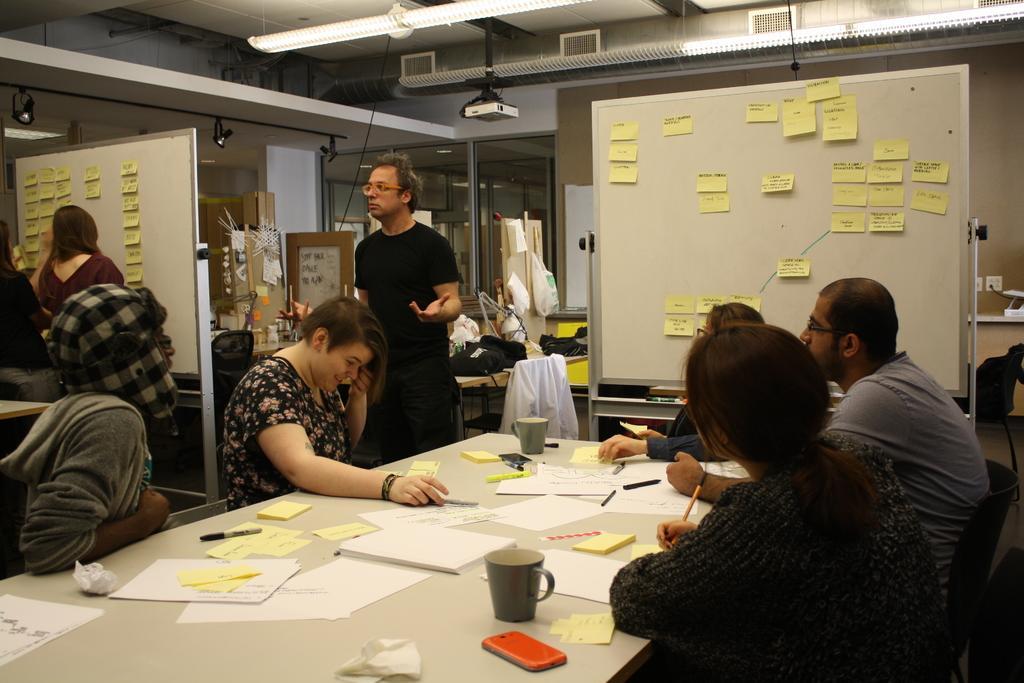Describe this image in one or two sentences. This picture describe about the inside view of the hall in which a group of girls and boys are sitting around the table and discussing something, On the table we can see papers, Yellow sticky notes, tea cup and mobile. Behind a white board with yellow stick notes and man wearing black t- shirt and track is discussing. On the top ceiling we can see the projector hanging and some ac pipes are fitted. 